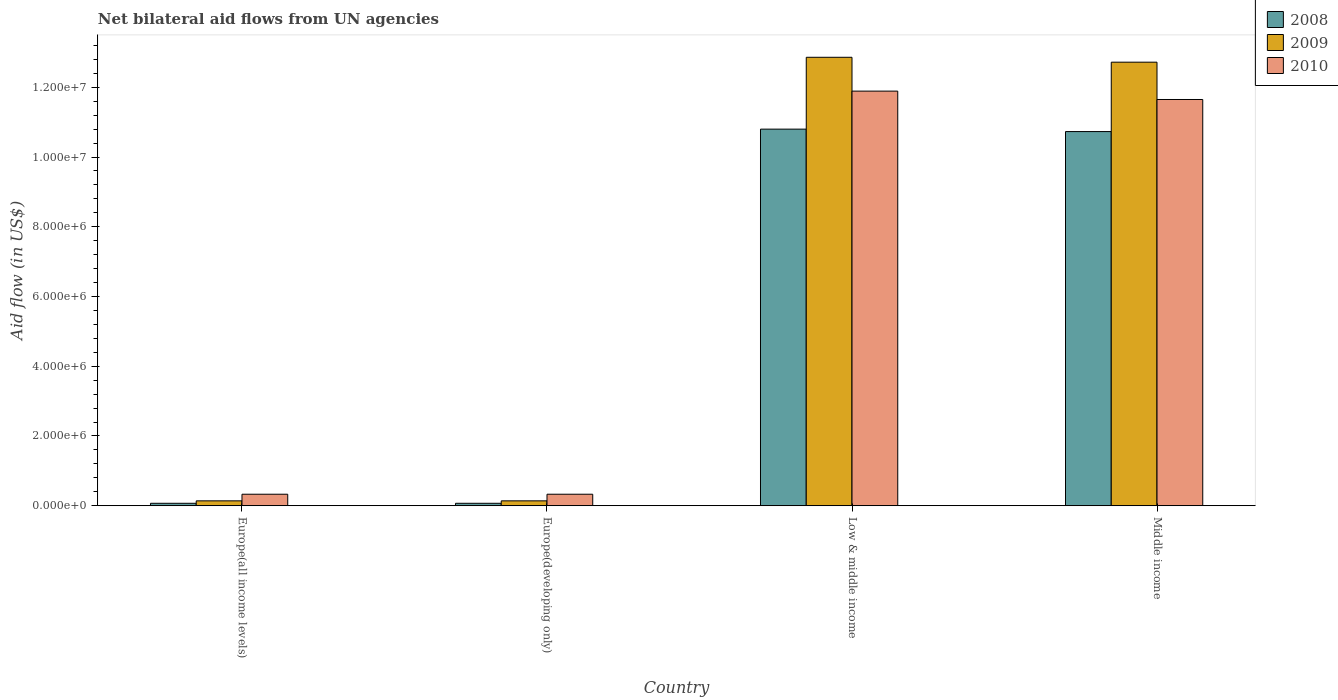How many different coloured bars are there?
Offer a terse response. 3. How many groups of bars are there?
Keep it short and to the point. 4. Are the number of bars on each tick of the X-axis equal?
Ensure brevity in your answer.  Yes. How many bars are there on the 1st tick from the left?
Your answer should be very brief. 3. How many bars are there on the 1st tick from the right?
Provide a succinct answer. 3. In how many cases, is the number of bars for a given country not equal to the number of legend labels?
Ensure brevity in your answer.  0. Across all countries, what is the maximum net bilateral aid flow in 2009?
Your answer should be compact. 1.29e+07. Across all countries, what is the minimum net bilateral aid flow in 2009?
Offer a terse response. 1.40e+05. In which country was the net bilateral aid flow in 2010 minimum?
Provide a succinct answer. Europe(all income levels). What is the total net bilateral aid flow in 2009 in the graph?
Your response must be concise. 2.59e+07. What is the difference between the net bilateral aid flow in 2010 in Europe(all income levels) and that in Low & middle income?
Your answer should be very brief. -1.16e+07. What is the difference between the net bilateral aid flow in 2009 in Middle income and the net bilateral aid flow in 2008 in Europe(all income levels)?
Offer a very short reply. 1.26e+07. What is the average net bilateral aid flow in 2009 per country?
Provide a succinct answer. 6.46e+06. What is the difference between the net bilateral aid flow of/in 2008 and net bilateral aid flow of/in 2010 in Low & middle income?
Provide a succinct answer. -1.09e+06. In how many countries, is the net bilateral aid flow in 2008 greater than 12400000 US$?
Your answer should be very brief. 0. What is the ratio of the net bilateral aid flow in 2010 in Europe(all income levels) to that in Low & middle income?
Provide a succinct answer. 0.03. Is the net bilateral aid flow in 2008 in Low & middle income less than that in Middle income?
Offer a very short reply. No. What is the difference between the highest and the second highest net bilateral aid flow in 2009?
Offer a very short reply. 1.27e+07. What is the difference between the highest and the lowest net bilateral aid flow in 2009?
Ensure brevity in your answer.  1.27e+07. Is the sum of the net bilateral aid flow in 2008 in Europe(developing only) and Middle income greater than the maximum net bilateral aid flow in 2009 across all countries?
Your answer should be very brief. No. What does the 3rd bar from the left in Low & middle income represents?
Make the answer very short. 2010. Are all the bars in the graph horizontal?
Your answer should be compact. No. How many countries are there in the graph?
Offer a very short reply. 4. Are the values on the major ticks of Y-axis written in scientific E-notation?
Provide a short and direct response. Yes. Does the graph contain grids?
Provide a succinct answer. No. Where does the legend appear in the graph?
Ensure brevity in your answer.  Top right. How many legend labels are there?
Your answer should be compact. 3. What is the title of the graph?
Make the answer very short. Net bilateral aid flows from UN agencies. What is the label or title of the X-axis?
Provide a short and direct response. Country. What is the label or title of the Y-axis?
Keep it short and to the point. Aid flow (in US$). What is the Aid flow (in US$) in 2008 in Europe(all income levels)?
Provide a succinct answer. 7.00e+04. What is the Aid flow (in US$) of 2008 in Low & middle income?
Your response must be concise. 1.08e+07. What is the Aid flow (in US$) of 2009 in Low & middle income?
Your answer should be compact. 1.29e+07. What is the Aid flow (in US$) of 2010 in Low & middle income?
Give a very brief answer. 1.19e+07. What is the Aid flow (in US$) of 2008 in Middle income?
Provide a succinct answer. 1.07e+07. What is the Aid flow (in US$) in 2009 in Middle income?
Give a very brief answer. 1.27e+07. What is the Aid flow (in US$) of 2010 in Middle income?
Your answer should be compact. 1.16e+07. Across all countries, what is the maximum Aid flow (in US$) of 2008?
Your answer should be very brief. 1.08e+07. Across all countries, what is the maximum Aid flow (in US$) of 2009?
Provide a short and direct response. 1.29e+07. Across all countries, what is the maximum Aid flow (in US$) in 2010?
Your answer should be very brief. 1.19e+07. Across all countries, what is the minimum Aid flow (in US$) of 2010?
Your response must be concise. 3.30e+05. What is the total Aid flow (in US$) of 2008 in the graph?
Give a very brief answer. 2.17e+07. What is the total Aid flow (in US$) of 2009 in the graph?
Offer a very short reply. 2.59e+07. What is the total Aid flow (in US$) of 2010 in the graph?
Ensure brevity in your answer.  2.42e+07. What is the difference between the Aid flow (in US$) of 2010 in Europe(all income levels) and that in Europe(developing only)?
Provide a short and direct response. 0. What is the difference between the Aid flow (in US$) of 2008 in Europe(all income levels) and that in Low & middle income?
Keep it short and to the point. -1.07e+07. What is the difference between the Aid flow (in US$) of 2009 in Europe(all income levels) and that in Low & middle income?
Keep it short and to the point. -1.27e+07. What is the difference between the Aid flow (in US$) of 2010 in Europe(all income levels) and that in Low & middle income?
Keep it short and to the point. -1.16e+07. What is the difference between the Aid flow (in US$) of 2008 in Europe(all income levels) and that in Middle income?
Offer a terse response. -1.07e+07. What is the difference between the Aid flow (in US$) of 2009 in Europe(all income levels) and that in Middle income?
Keep it short and to the point. -1.26e+07. What is the difference between the Aid flow (in US$) of 2010 in Europe(all income levels) and that in Middle income?
Keep it short and to the point. -1.13e+07. What is the difference between the Aid flow (in US$) of 2008 in Europe(developing only) and that in Low & middle income?
Provide a succinct answer. -1.07e+07. What is the difference between the Aid flow (in US$) in 2009 in Europe(developing only) and that in Low & middle income?
Make the answer very short. -1.27e+07. What is the difference between the Aid flow (in US$) of 2010 in Europe(developing only) and that in Low & middle income?
Your response must be concise. -1.16e+07. What is the difference between the Aid flow (in US$) in 2008 in Europe(developing only) and that in Middle income?
Provide a succinct answer. -1.07e+07. What is the difference between the Aid flow (in US$) of 2009 in Europe(developing only) and that in Middle income?
Offer a terse response. -1.26e+07. What is the difference between the Aid flow (in US$) in 2010 in Europe(developing only) and that in Middle income?
Your answer should be compact. -1.13e+07. What is the difference between the Aid flow (in US$) in 2008 in Low & middle income and that in Middle income?
Ensure brevity in your answer.  7.00e+04. What is the difference between the Aid flow (in US$) in 2009 in Low & middle income and that in Middle income?
Offer a terse response. 1.40e+05. What is the difference between the Aid flow (in US$) in 2008 in Europe(all income levels) and the Aid flow (in US$) in 2009 in Low & middle income?
Provide a short and direct response. -1.28e+07. What is the difference between the Aid flow (in US$) of 2008 in Europe(all income levels) and the Aid flow (in US$) of 2010 in Low & middle income?
Make the answer very short. -1.18e+07. What is the difference between the Aid flow (in US$) of 2009 in Europe(all income levels) and the Aid flow (in US$) of 2010 in Low & middle income?
Offer a terse response. -1.18e+07. What is the difference between the Aid flow (in US$) in 2008 in Europe(all income levels) and the Aid flow (in US$) in 2009 in Middle income?
Provide a short and direct response. -1.26e+07. What is the difference between the Aid flow (in US$) in 2008 in Europe(all income levels) and the Aid flow (in US$) in 2010 in Middle income?
Provide a succinct answer. -1.16e+07. What is the difference between the Aid flow (in US$) in 2009 in Europe(all income levels) and the Aid flow (in US$) in 2010 in Middle income?
Offer a terse response. -1.15e+07. What is the difference between the Aid flow (in US$) of 2008 in Europe(developing only) and the Aid flow (in US$) of 2009 in Low & middle income?
Keep it short and to the point. -1.28e+07. What is the difference between the Aid flow (in US$) in 2008 in Europe(developing only) and the Aid flow (in US$) in 2010 in Low & middle income?
Offer a very short reply. -1.18e+07. What is the difference between the Aid flow (in US$) in 2009 in Europe(developing only) and the Aid flow (in US$) in 2010 in Low & middle income?
Your answer should be very brief. -1.18e+07. What is the difference between the Aid flow (in US$) in 2008 in Europe(developing only) and the Aid flow (in US$) in 2009 in Middle income?
Your answer should be very brief. -1.26e+07. What is the difference between the Aid flow (in US$) in 2008 in Europe(developing only) and the Aid flow (in US$) in 2010 in Middle income?
Keep it short and to the point. -1.16e+07. What is the difference between the Aid flow (in US$) of 2009 in Europe(developing only) and the Aid flow (in US$) of 2010 in Middle income?
Give a very brief answer. -1.15e+07. What is the difference between the Aid flow (in US$) in 2008 in Low & middle income and the Aid flow (in US$) in 2009 in Middle income?
Provide a short and direct response. -1.92e+06. What is the difference between the Aid flow (in US$) in 2008 in Low & middle income and the Aid flow (in US$) in 2010 in Middle income?
Give a very brief answer. -8.50e+05. What is the difference between the Aid flow (in US$) of 2009 in Low & middle income and the Aid flow (in US$) of 2010 in Middle income?
Make the answer very short. 1.21e+06. What is the average Aid flow (in US$) in 2008 per country?
Your answer should be compact. 5.42e+06. What is the average Aid flow (in US$) in 2009 per country?
Give a very brief answer. 6.46e+06. What is the average Aid flow (in US$) in 2010 per country?
Your answer should be very brief. 6.05e+06. What is the difference between the Aid flow (in US$) of 2009 and Aid flow (in US$) of 2010 in Europe(all income levels)?
Provide a short and direct response. -1.90e+05. What is the difference between the Aid flow (in US$) of 2009 and Aid flow (in US$) of 2010 in Europe(developing only)?
Make the answer very short. -1.90e+05. What is the difference between the Aid flow (in US$) of 2008 and Aid flow (in US$) of 2009 in Low & middle income?
Make the answer very short. -2.06e+06. What is the difference between the Aid flow (in US$) of 2008 and Aid flow (in US$) of 2010 in Low & middle income?
Keep it short and to the point. -1.09e+06. What is the difference between the Aid flow (in US$) in 2009 and Aid flow (in US$) in 2010 in Low & middle income?
Your answer should be very brief. 9.70e+05. What is the difference between the Aid flow (in US$) in 2008 and Aid flow (in US$) in 2009 in Middle income?
Your answer should be compact. -1.99e+06. What is the difference between the Aid flow (in US$) in 2008 and Aid flow (in US$) in 2010 in Middle income?
Offer a terse response. -9.20e+05. What is the difference between the Aid flow (in US$) of 2009 and Aid flow (in US$) of 2010 in Middle income?
Offer a terse response. 1.07e+06. What is the ratio of the Aid flow (in US$) in 2008 in Europe(all income levels) to that in Europe(developing only)?
Provide a succinct answer. 1. What is the ratio of the Aid flow (in US$) of 2009 in Europe(all income levels) to that in Europe(developing only)?
Your answer should be compact. 1. What is the ratio of the Aid flow (in US$) of 2008 in Europe(all income levels) to that in Low & middle income?
Your answer should be compact. 0.01. What is the ratio of the Aid flow (in US$) in 2009 in Europe(all income levels) to that in Low & middle income?
Ensure brevity in your answer.  0.01. What is the ratio of the Aid flow (in US$) of 2010 in Europe(all income levels) to that in Low & middle income?
Your answer should be very brief. 0.03. What is the ratio of the Aid flow (in US$) in 2008 in Europe(all income levels) to that in Middle income?
Your answer should be compact. 0.01. What is the ratio of the Aid flow (in US$) in 2009 in Europe(all income levels) to that in Middle income?
Your answer should be compact. 0.01. What is the ratio of the Aid flow (in US$) in 2010 in Europe(all income levels) to that in Middle income?
Keep it short and to the point. 0.03. What is the ratio of the Aid flow (in US$) in 2008 in Europe(developing only) to that in Low & middle income?
Provide a succinct answer. 0.01. What is the ratio of the Aid flow (in US$) of 2009 in Europe(developing only) to that in Low & middle income?
Make the answer very short. 0.01. What is the ratio of the Aid flow (in US$) in 2010 in Europe(developing only) to that in Low & middle income?
Ensure brevity in your answer.  0.03. What is the ratio of the Aid flow (in US$) of 2008 in Europe(developing only) to that in Middle income?
Provide a succinct answer. 0.01. What is the ratio of the Aid flow (in US$) of 2009 in Europe(developing only) to that in Middle income?
Keep it short and to the point. 0.01. What is the ratio of the Aid flow (in US$) of 2010 in Europe(developing only) to that in Middle income?
Ensure brevity in your answer.  0.03. What is the ratio of the Aid flow (in US$) in 2008 in Low & middle income to that in Middle income?
Give a very brief answer. 1.01. What is the ratio of the Aid flow (in US$) in 2009 in Low & middle income to that in Middle income?
Keep it short and to the point. 1.01. What is the ratio of the Aid flow (in US$) of 2010 in Low & middle income to that in Middle income?
Provide a short and direct response. 1.02. What is the difference between the highest and the second highest Aid flow (in US$) in 2008?
Your answer should be compact. 7.00e+04. What is the difference between the highest and the second highest Aid flow (in US$) in 2009?
Provide a short and direct response. 1.40e+05. What is the difference between the highest and the second highest Aid flow (in US$) in 2010?
Give a very brief answer. 2.40e+05. What is the difference between the highest and the lowest Aid flow (in US$) of 2008?
Provide a succinct answer. 1.07e+07. What is the difference between the highest and the lowest Aid flow (in US$) of 2009?
Provide a short and direct response. 1.27e+07. What is the difference between the highest and the lowest Aid flow (in US$) of 2010?
Your answer should be very brief. 1.16e+07. 